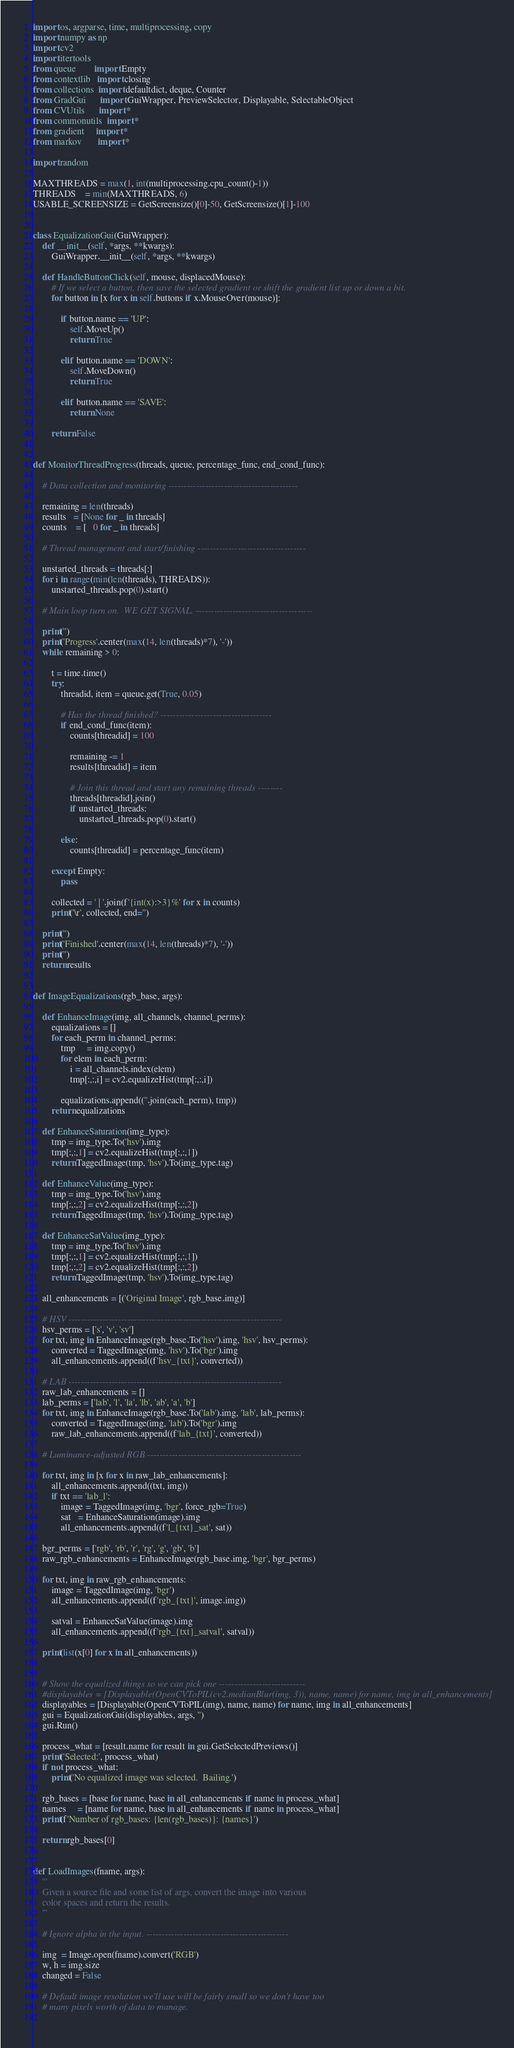<code> <loc_0><loc_0><loc_500><loc_500><_Cython_>import os, argparse, time, multiprocessing, copy
import numpy as np
import cv2
import itertools
from queue        import Empty
from contextlib   import closing
from collections  import defaultdict, deque, Counter
from GradGui      import GuiWrapper, PreviewSelector, Displayable, SelectableObject
from CVUtils      import *
from commonutils  import *
from gradient     import *
from markov       import *

import random

MAXTHREADS = max(1, int(multiprocessing.cpu_count()-1))
THREADS    = min(MAXTHREADS, 6)
USABLE_SCREENSIZE = GetScreensize()[0]-50, GetScreensize()[1]-100

	
class EqualizationGui(GuiWrapper):
	def __init__(self, *args, **kwargs):
		GuiWrapper.__init__(self, *args, **kwargs)

	def HandleButtonClick(self, mouse, displacedMouse):
		# If we select a button, then save the selected gradient or shift the gradient list up or down a bit.
		for button in [x for x in self.buttons if x.MouseOver(mouse)]:
	
			if button.name == 'UP':
				self.MoveUp()
				return True
				
			elif button.name == 'DOWN':
				self.MoveDown()
				return True
				
			elif button.name == 'SAVE':
				return None
				
		return False
	
	
def MonitorThreadProgress(threads, queue, percentage_func, end_cond_func):

	# Data collection and monitoring ------------------------------------------
	
	remaining = len(threads)
	results   = [None for _ in threads]
	counts    = [   0 for _ in threads]
	
	# Thread management and start/finishing -----------------------------------
	
	unstarted_threads = threads[:]
	for i in range(min(len(threads), THREADS)):
		unstarted_threads.pop(0).start()
		
	# Main loop turn on.  WE GET SIGNAL. --------------------------------------
	
	print('')
	print('Progress'.center(max(14, len(threads)*7), '-'))
	while remaining > 0:
	
		t = time.time()
		try:			
			threadid, item = queue.get(True, 0.05)
			
			# Has the thread finished? ------------------------------------
			if end_cond_func(item):
				counts[threadid] = 100
			
				remaining -= 1
				results[threadid] = item
				
				# Join this thread and start any remaining threads --------
				threads[threadid].join()
				if unstarted_threads:
					unstarted_threads.pop(0).start()
					
			else:
				counts[threadid] = percentage_func(item)
					
		except Empty:
			pass
			
		collected = ' | '.join(f'{int(x):>3}%' for x in counts)
		print('\r', collected, end='')
		
	print('')
	print('Finished'.center(max(14, len(threads)*7), '-'))
	print('')
	return results
	
	
def ImageEqualizations(rgb_base, args):

	def EnhanceImage(img, all_channels, channel_perms):
		equalizations = []
		for each_perm in channel_perms:
			tmp     = img.copy()
			for elem in each_perm:
				i = all_channels.index(elem)
				tmp[:,:,i] = cv2.equalizeHist(tmp[:,:,i])

			equalizations.append((''.join(each_perm), tmp))
		return equalizations
		
	def EnhanceSaturation(img_type):
		tmp = img_type.To('hsv').img
		tmp[:,:,1] = cv2.equalizeHist(tmp[:,:,1])
		return TaggedImage(tmp, 'hsv').To(img_type.tag)
		
	def EnhanceValue(img_type):
		tmp = img_type.To('hsv').img
		tmp[:,:,2] = cv2.equalizeHist(tmp[:,:,2])
		return TaggedImage(tmp, 'hsv').To(img_type.tag)
		
	def EnhanceSatValue(img_type):
		tmp = img_type.To('hsv').img
		tmp[:,:,1] = cv2.equalizeHist(tmp[:,:,1])
		tmp[:,:,2] = cv2.equalizeHist(tmp[:,:,2])
		return TaggedImage(tmp, 'hsv').To(img_type.tag)
		
	all_enhancements = [('Original Image', rgb_base.img)]

	# HSV ---------------------------------------------------------------------
	hsv_perms = ['s', 'v', 'sv']
	for txt, img in EnhanceImage(rgb_base.To('hsv').img, 'hsv', hsv_perms):
		converted = TaggedImage(img, 'hsv').To('bgr').img
		all_enhancements.append((f'hsv_{txt}', converted))
		
	# LAB ---------------------------------------------------------------------
	raw_lab_enhancements = []
	lab_perms = ['lab', 'l', 'la', 'lb', 'ab', 'a', 'b']
	for txt, img in EnhanceImage(rgb_base.To('lab').img, 'lab', lab_perms):
		converted = TaggedImage(img, 'lab').To('bgr').img
		raw_lab_enhancements.append((f'lab_{txt}', converted))

	# Luminance-adjusted RGB --------------------------------------------------

	for txt, img in [x for x in raw_lab_enhancements]:
		all_enhancements.append((txt, img))
		if txt == 'lab_l':
			image = TaggedImage(img, 'bgr', force_rgb=True)
			sat   = EnhanceSaturation(image).img
			all_enhancements.append((f'l_{txt}_sat', sat))
	
	bgr_perms = ['rgb', 'rb', 'r', 'rg', 'g', 'gb', 'b']
	raw_rgb_enhancements = EnhanceImage(rgb_base.img, 'bgr', bgr_perms)
	
	for txt, img in raw_rgb_enhancements:	
		image = TaggedImage(img, 'bgr')
		all_enhancements.append((f'rgb_{txt}', image.img))
		
		satval = EnhanceSatValue(image).img
		all_enhancements.append((f'rgb_{txt}_satval', satval))
		
	print(list(x[0] for x in all_enhancements))

	
	# Show the equalized things so we can pick one ----------------------------	
	#displayables = [Displayable(OpenCVToPIL(cv2.medianBlur(img, 3)), name, name) for name, img in all_enhancements]
	displayables = [Displayable(OpenCVToPIL(img), name, name) for name, img in all_enhancements]
	gui = EqualizationGui(displayables, args, '')
	gui.Run()
	
	process_what = [result.name for result in gui.GetSelectedPreviews()]
	print('Selected:', process_what)
	if not process_what:
		print('No equalized image was selected.  Bailing.')	
	
	rgb_bases = [base for name, base in all_enhancements if name in process_what]
	names     = [name for name, base in all_enhancements if name in process_what]
	print(f'Number of rgb_bases: {len(rgb_bases)}: {names}')
		
	return rgb_bases[0]
		
		
def LoadImages(fname, args):
	'''
	Given a source file and some list of args, convert the image into various
	color spaces and return the results.
	'''
			
	# Ignore alpha in the input. ----------------------------------------------
	
	img  = Image.open(fname).convert('RGB')
	w, h = img.size
	changed = False
	
	# Default image resolution we'll use will be fairly small so we don't have too
	# many pixels worth of data to manage.
	</code> 